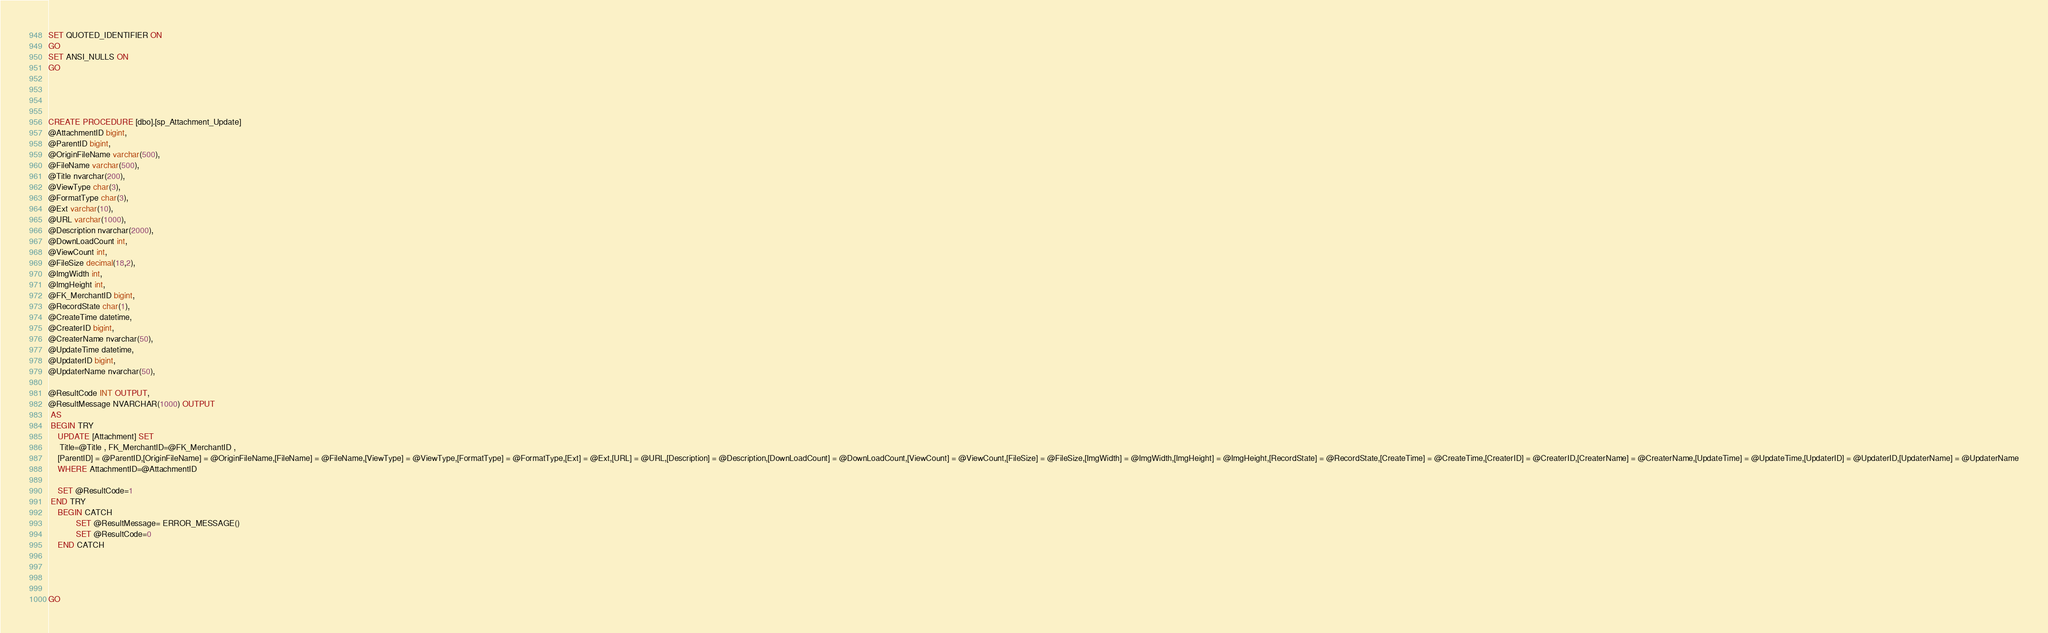Convert code to text. <code><loc_0><loc_0><loc_500><loc_500><_SQL_>
SET QUOTED_IDENTIFIER ON
GO
SET ANSI_NULLS ON
GO




CREATE PROCEDURE [dbo].[sp_Attachment_Update]
@AttachmentID bigint,
@ParentID bigint,
@OriginFileName varchar(500),
@FileName varchar(500),
@Title nvarchar(200),
@ViewType char(3),
@FormatType char(3),
@Ext varchar(10),
@URL varchar(1000),
@Description nvarchar(2000),
@DownLoadCount int,
@ViewCount int,
@FileSize decimal(18,2),
@ImgWidth int,
@ImgHeight int,
@FK_MerchantID bigint,
@RecordState char(1),
@CreateTime datetime,
@CreaterID bigint,
@CreaterName nvarchar(50),
@UpdateTime datetime,
@UpdaterID bigint,
@UpdaterName nvarchar(50),

@ResultCode INT OUTPUT,
@ResultMessage NVARCHAR(1000) OUTPUT
 AS 
 BEGIN TRY
	UPDATE [Attachment] SET 
	 Title=@Title , FK_MerchantID=@FK_MerchantID ,
	[ParentID] = @ParentID,[OriginFileName] = @OriginFileName,[FileName] = @FileName,[ViewType] = @ViewType,[FormatType] = @FormatType,[Ext] = @Ext,[URL] = @URL,[Description] = @Description,[DownLoadCount] = @DownLoadCount,[ViewCount] = @ViewCount,[FileSize] = @FileSize,[ImgWidth] = @ImgWidth,[ImgHeight] = @ImgHeight,[RecordState] = @RecordState,[CreateTime] = @CreateTime,[CreaterID] = @CreaterID,[CreaterName] = @CreaterName,[UpdateTime] = @UpdateTime,[UpdaterID] = @UpdaterID,[UpdaterName] = @UpdaterName
	WHERE AttachmentID=@AttachmentID

	SET @ResultCode=1
 END TRY
 	BEGIN CATCH
			SET @ResultMessage= ERROR_MESSAGE() 
			SET @ResultCode=0
	END CATCH




GO
</code> 